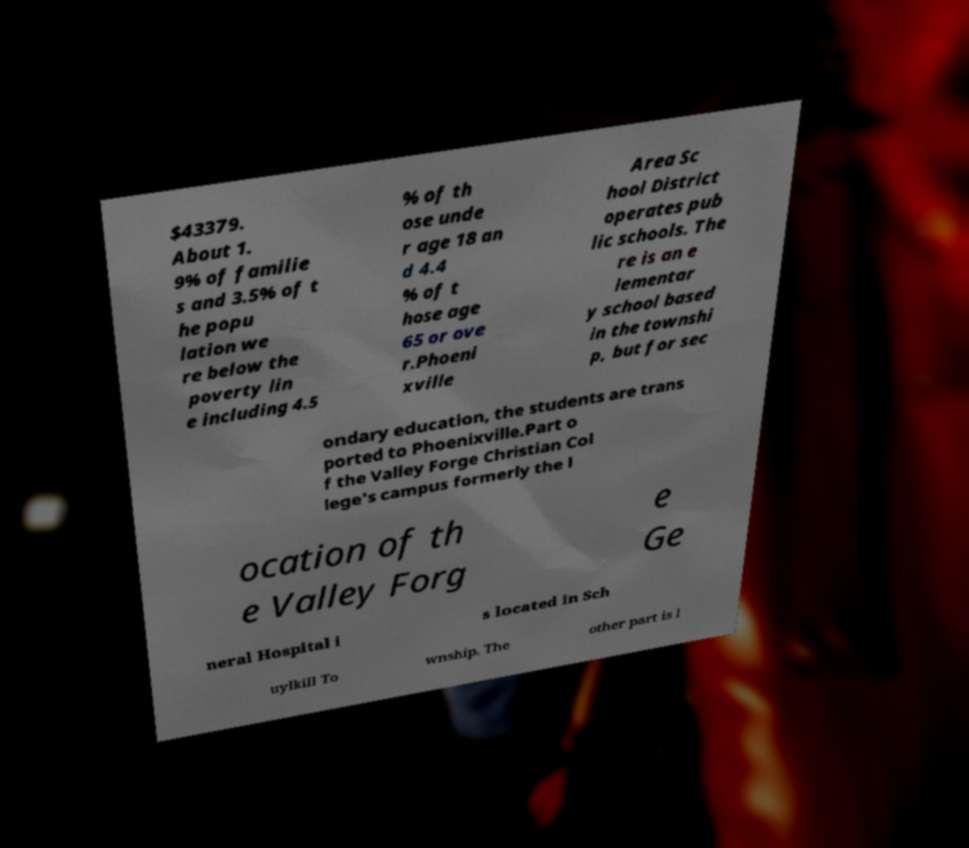Could you extract and type out the text from this image? $43379. About 1. 9% of familie s and 3.5% of t he popu lation we re below the poverty lin e including 4.5 % of th ose unde r age 18 an d 4.4 % of t hose age 65 or ove r.Phoeni xville Area Sc hool District operates pub lic schools. The re is an e lementar y school based in the townshi p, but for sec ondary education, the students are trans ported to Phoenixville.Part o f the Valley Forge Christian Col lege's campus formerly the l ocation of th e Valley Forg e Ge neral Hospital i s located in Sch uylkill To wnship. The other part is l 